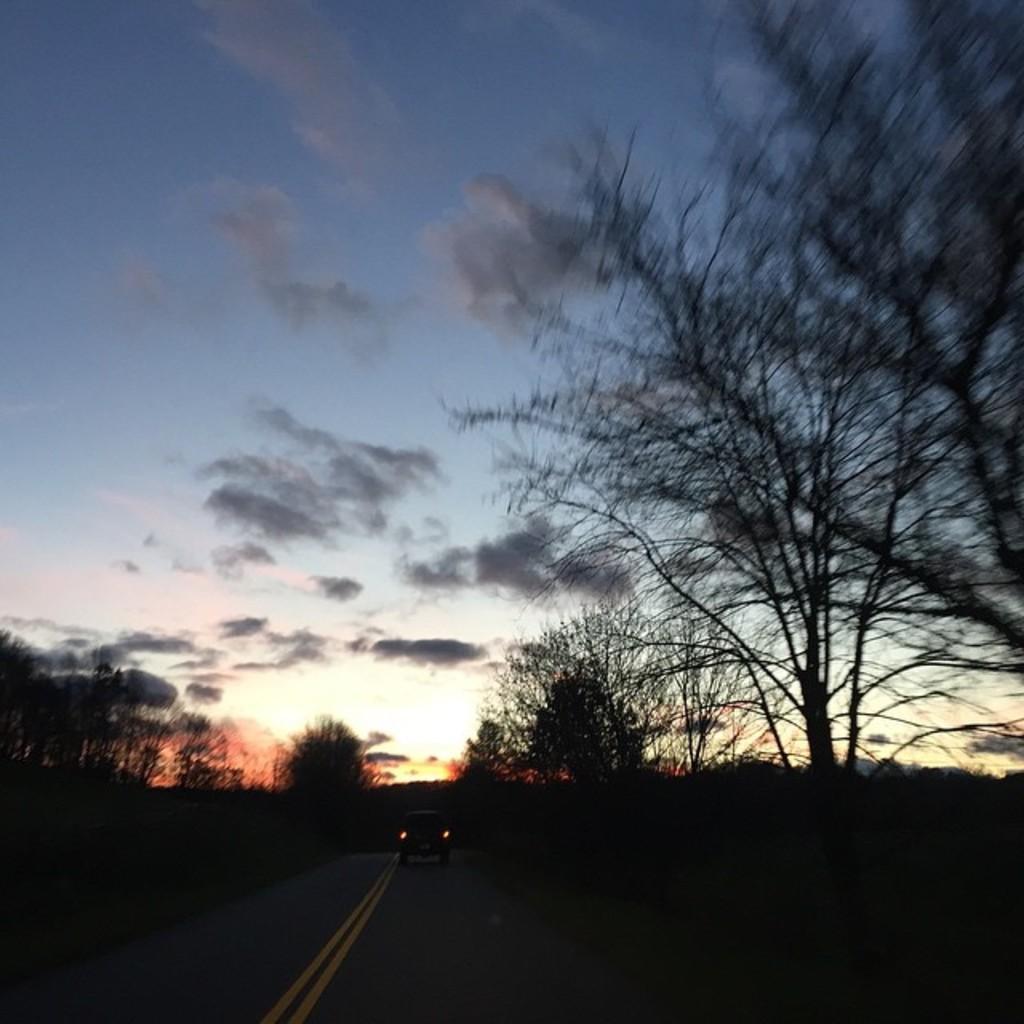How would you summarize this image in a sentence or two? These are clouds. Vehicle is on the road. Here we can see trees. 